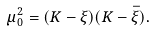Convert formula to latex. <formula><loc_0><loc_0><loc_500><loc_500>\mu _ { 0 } ^ { 2 } = ( K - \xi ) ( K - \bar { \xi } ) .</formula> 